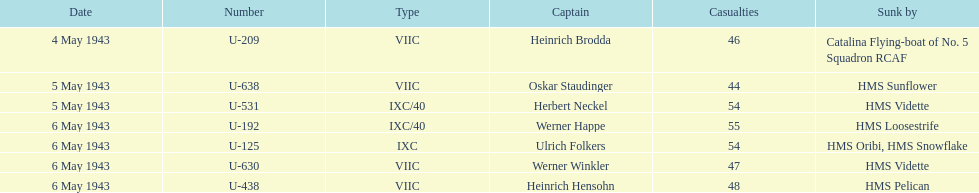Which date had at least 55 casualties? 6 May 1943. 